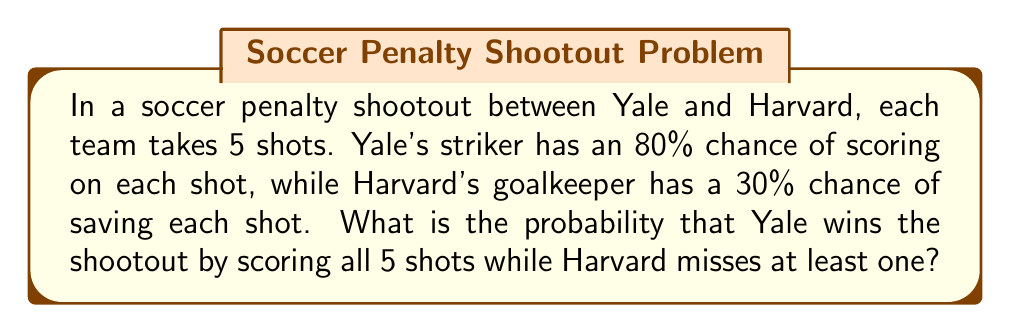Could you help me with this problem? Let's approach this step-by-step:

1) First, we need to calculate the probability of Yale scoring all 5 shots:
   $$P(\text{Yale scores all 5}) = 0.8^5 = 0.32768$$

2) Now, we need to calculate the probability of Harvard missing at least one shot:
   - The probability of Harvard scoring a single shot is $1 - 0.3 = 0.7$
   - The probability of Harvard scoring all 5 shots is $0.7^5 = 0.16807$
   - Therefore, the probability of Harvard missing at least one shot is:
     $$P(\text{Harvard misses at least one}) = 1 - 0.7^5 = 1 - 0.16807 = 0.83193$$

3) The probability of both events occurring (Yale scoring all 5 AND Harvard missing at least one) is the product of their individual probabilities:

   $$P(\text{Yale wins}) = P(\text{Yale scores all 5}) \times P(\text{Harvard misses at least one})$$
   $$= 0.32768 \times 0.83193 = 0.27261$$

4) Converting to a percentage:
   $$0.27261 \times 100\% = 27.261\%$$
Answer: 27.261% 